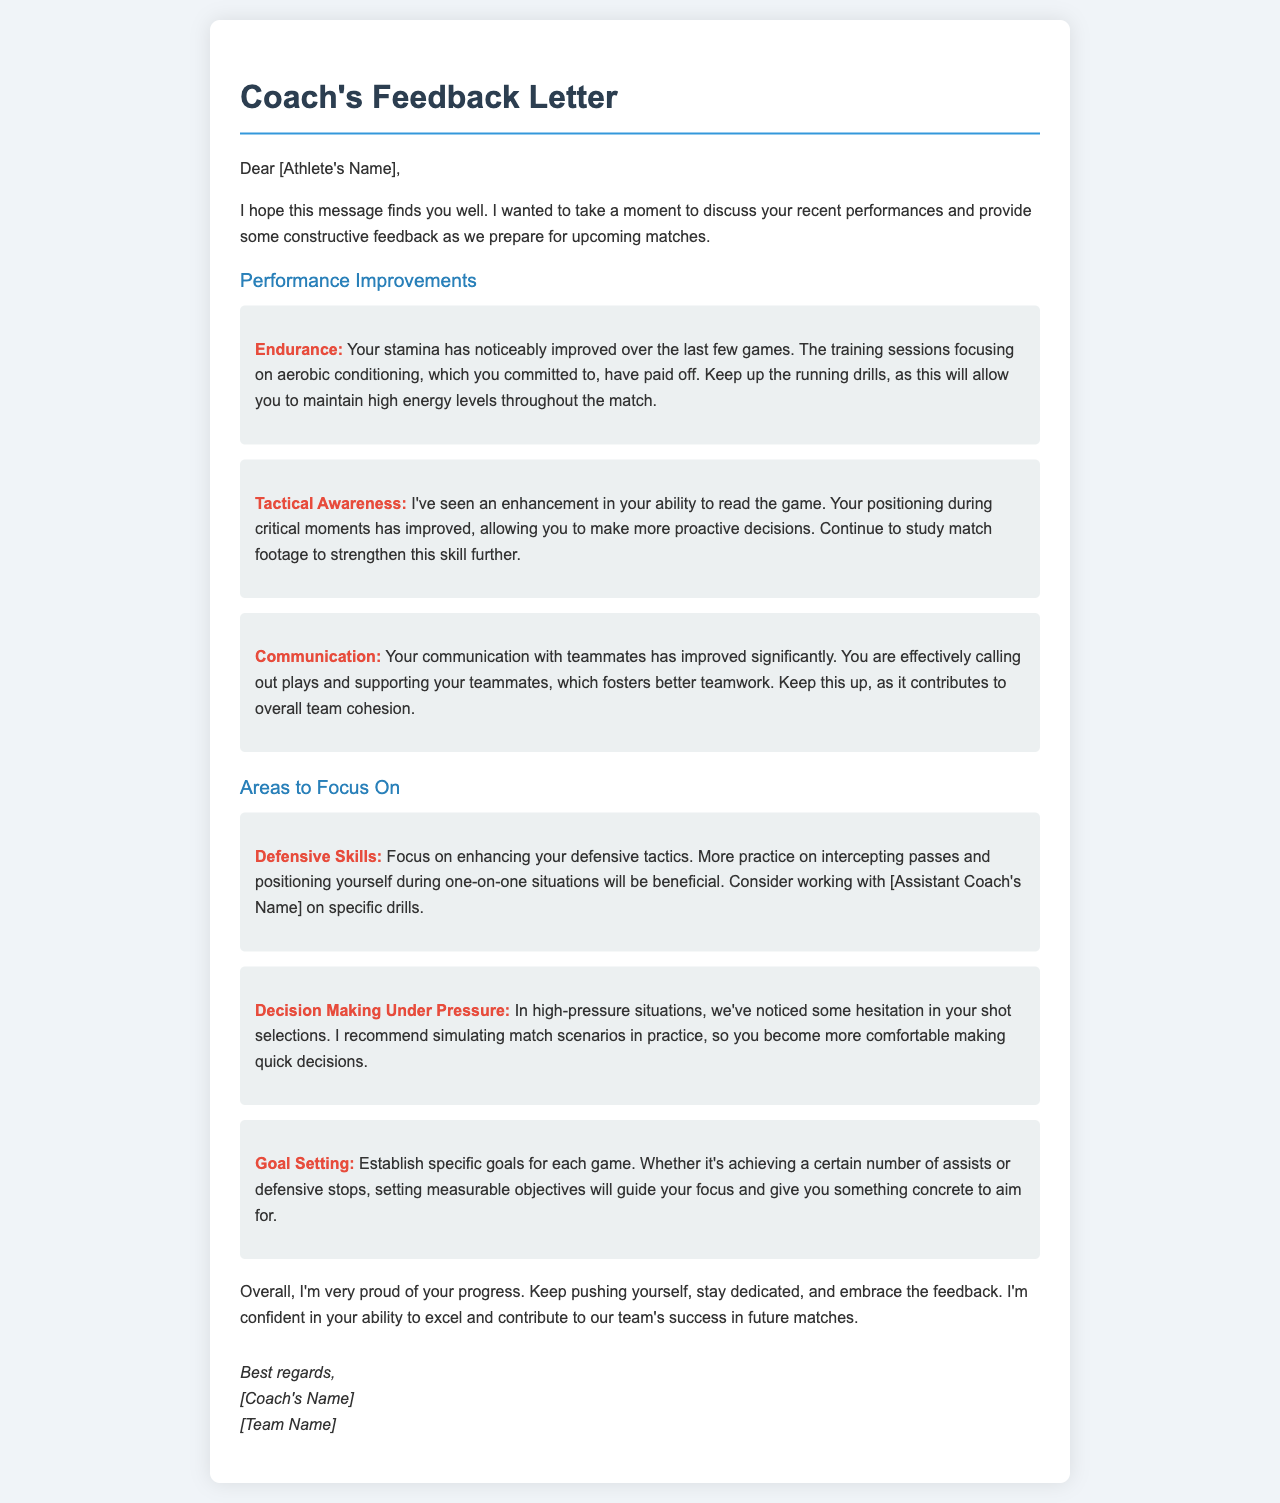What improvements in endurance were noted? The letter states that the athlete's stamina has noticeably improved over the last few games due to training sessions focusing on aerobic conditioning.
Answer: Stamina Who has helped with defensive skills drills? The letter suggests working with the assistant coach on specific drills to enhance defensive tactics.
Answer: Assistant Coach's Name What aspect of communication improved significantly? The letter mentions that the athlete is effectively calling out plays and supporting teammates, which contributes to better teamwork.
Answer: Team Cohesion What area requires more focus on decision-making? The document highlights the need for improving quick decisions during high-pressure situations in matches.
Answer: High-pressure situations What is recommended for enhancing tactical awareness? The coach recommends continuing to study match footage to strengthen this skill further.
Answer: Study match footage What specific focus area does the coach suggest for goal setting? The coach advises establishing specific goals for each game to guide focus and objectives.
Answer: Specific goals 